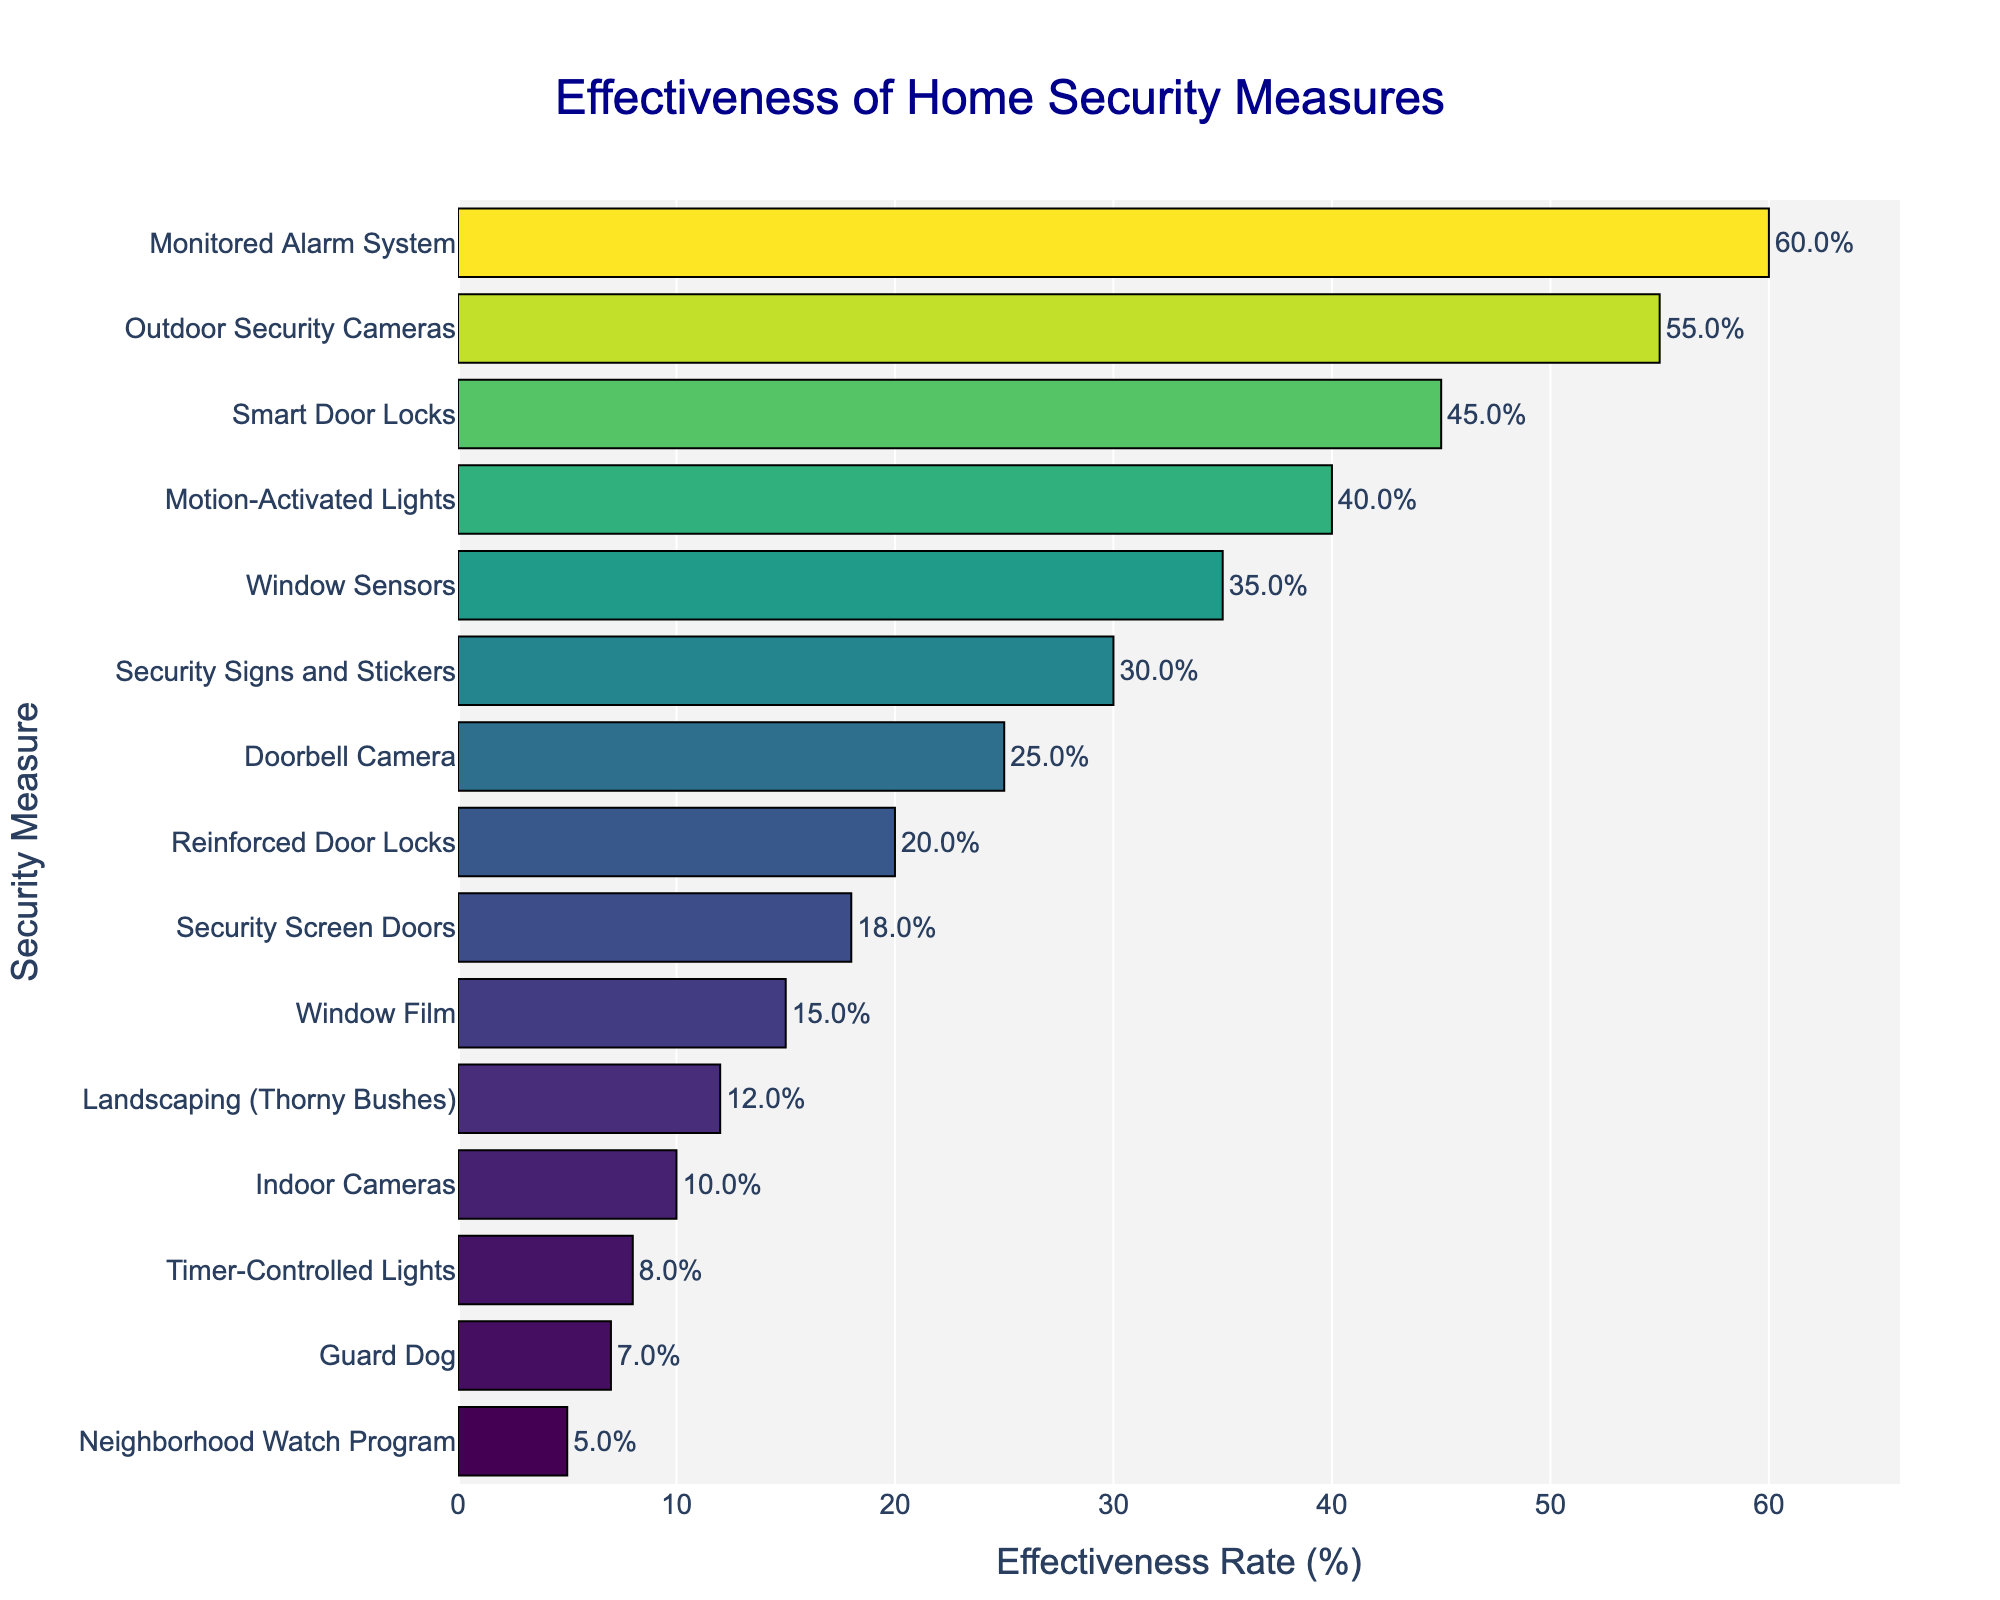What's the most effective home security measure according to the chart? The chart shows different home security measures and their effectiveness rates in percentage. The bar representing "Monitored Alarm System" is the longest.
Answer: Monitored Alarm System Which is more effective, Outdoor Security Cameras or Smart Door Locks? By comparing the bars for "Outdoor Security Cameras" and "Smart Door Locks", we see that the bar for "Outdoor Security Cameras" is longer, indicating a higher effectiveness rate.
Answer: Outdoor Security Cameras What is the effectiveness rate of Security Signs and Stickers? The bar for "Security Signs and Stickers" reaches the 30% mark on the x-axis.
Answer: 30% How much more effective are Motion-Activated Lights compared to a Guard Dog? Motion-Activated Lights have a 40% effectiveness rate, while a Guard Dog has 7%. Subtracting 7% from 40% gives us the difference.
Answer: 33% Which security measure is the least effective? The shortest bar in the chart represents the "Neighborhood Watch Program".
Answer: Neighborhood Watch Program What are the total effectiveness rates of the top three measures? The top three measures are Monitored Alarm System (60%), Outdoor Security Cameras (55%), and Smart Door Locks (45%). Adding them we get 60 + 55 + 45 = 160.
Answer: 160% How does the effectiveness of Window Sensors compare to Timer-Controlled Lights and Security Screen Doors? Window Sensors have an effectiveness rate of 35%, Timer-Controlled Lights have 8%, and Security Screen Doors have 18%. Window Sensors are more effective than both other measures.
Answer: Window Sensors are more effective Which measure is barely more effective than Indoor Cameras? The bar for "Timer-Controlled Lights" is just a bit longer than the one for "Indoor Cameras", indicating it is slightly more effective.
Answer: Timer-Controlled Lights By how many percentage points are Timer-Controlled Lights less effective than Window Film? Timer-Controlled Lights are at 8% effectiveness, and Window Film is at 15%. Subtracting 8% from 15% gives us 7%.
Answer: 7% What is the average effectiveness rate of the three least effective measures? The least effective measures are Neighborhood Watch Program (5%), Guard Dog (7%), and Timer-Controlled Lights (8%). The average is (5 + 7 + 8) / 3 = 6.67%.
Answer: 6.67% 